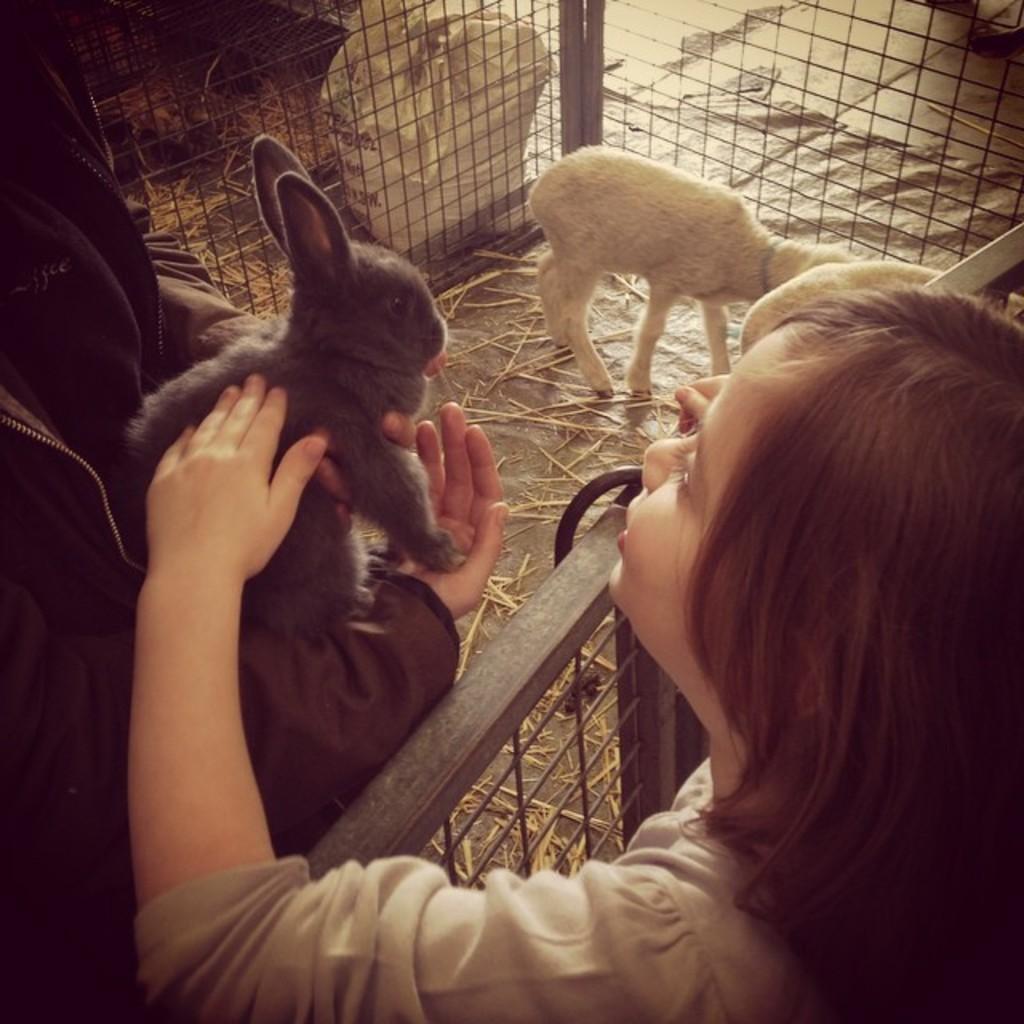In one or two sentences, can you explain what this image depicts? In this picture there is a girl who is a standing near to the fencing. On the left I can see the person who is wearing jacket and holding a black rabbit. In the top right there is a white color goat on the floor. Beside the goat I can see some grass. At the top I can see the plastic cover which is placed near to the fencing. 